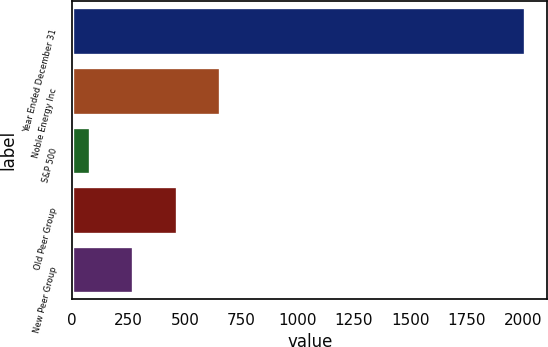<chart> <loc_0><loc_0><loc_500><loc_500><bar_chart><fcel>Year Ended December 31<fcel>Noble Energy Inc<fcel>S&P 500<fcel>Old Peer Group<fcel>New Peer Group<nl><fcel>2008<fcel>656.26<fcel>76.96<fcel>463.16<fcel>270.06<nl></chart> 